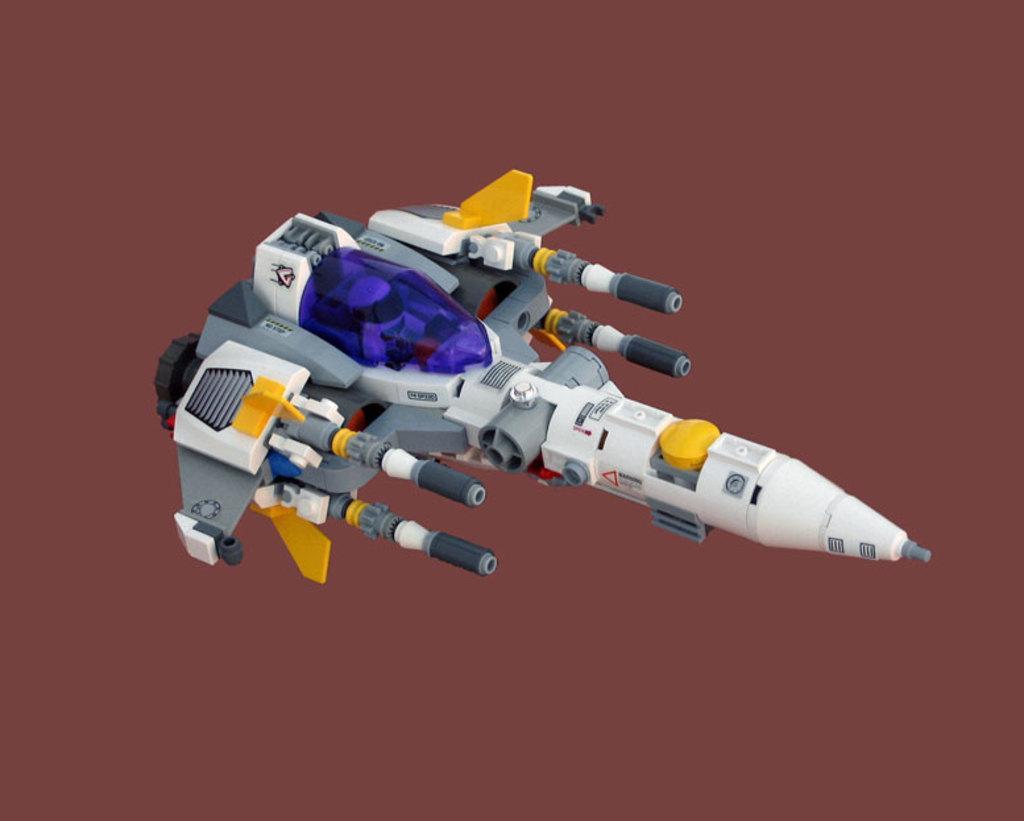Describe this image in one or two sentences. In the picture I can see a plane toy which is in different colors and the background is in brown color. 